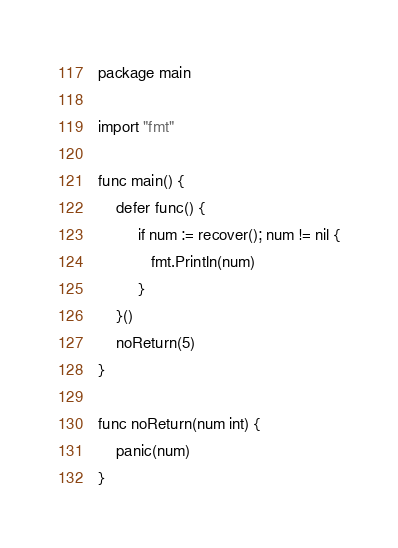<code> <loc_0><loc_0><loc_500><loc_500><_Go_>package main

import "fmt"

func main() {
	defer func() {
		 if num := recover(); num != nil {
		 	fmt.Println(num)
		 }
	}()
	noReturn(5)
}

func noReturn(num int) {
	panic(num)
}
</code> 